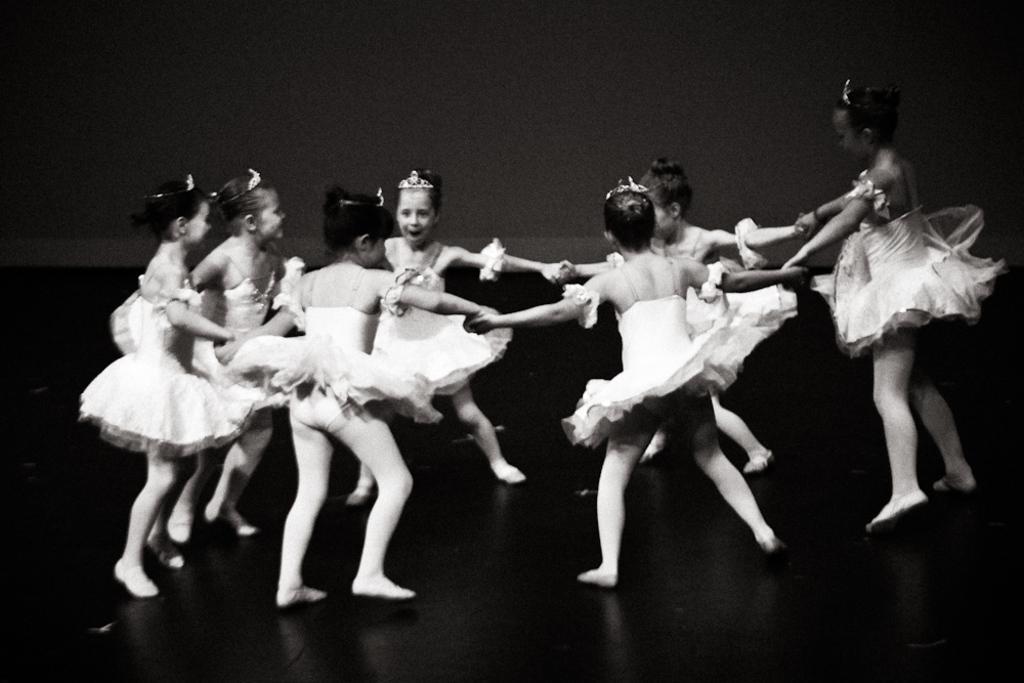Can you describe this image briefly? In the picture we can see some girls are dancing, holding each other hand. 